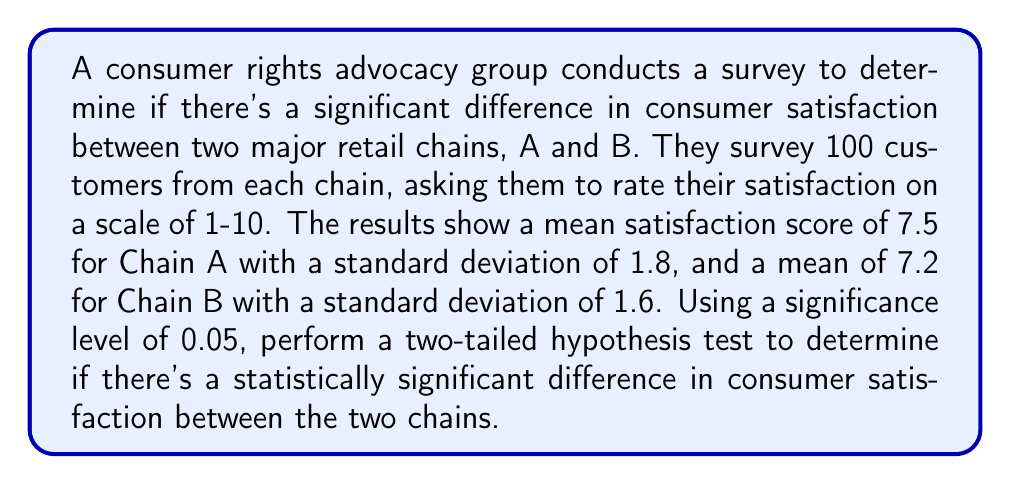Can you solve this math problem? To analyze the statistical significance of these survey results, we'll use a two-sample t-test. Here's the step-by-step process:

1. State the hypotheses:
   $H_0: \mu_A - \mu_B = 0$ (null hypothesis)
   $H_a: \mu_A - \mu_B \neq 0$ (alternative hypothesis)

2. Calculate the pooled standard error:
   $SE = \sqrt{\frac{s_A^2}{n_A} + \frac{s_B^2}{n_B}}$
   $SE = \sqrt{\frac{1.8^2}{100} + \frac{1.6^2}{100}} = 0.24$

3. Calculate the t-statistic:
   $t = \frac{(\bar{x}_A - \bar{x}_B) - (\mu_A - \mu_B)}{SE}$
   $t = \frac{(7.5 - 7.2) - 0}{0.24} = 1.25$

4. Determine the critical t-value:
   For a two-tailed test with α = 0.05 and df = n_A + n_B - 2 = 198, the critical t-value is approximately ±1.97.

5. Compare the t-statistic to the critical value:
   |1.25| < 1.97

6. Calculate the p-value:
   Using a t-distribution calculator or table, we find that the p-value for t = 1.25 with df = 198 is approximately 0.213.

7. Compare the p-value to the significance level:
   0.213 > 0.05

Since the absolute value of the t-statistic is less than the critical value and the p-value is greater than the significance level, we fail to reject the null hypothesis.
Answer: Fail to reject $H_0$; no statistically significant difference in consumer satisfaction between the two retail chains. 